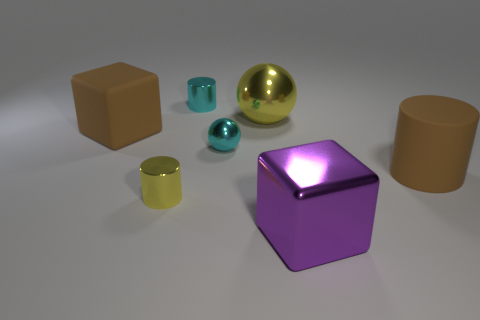Are there any large cubes in front of the yellow ball?
Provide a succinct answer. Yes. Are there any other tiny metallic objects of the same shape as the purple object?
Your answer should be compact. No. There is a yellow thing that is the same size as the brown rubber block; what shape is it?
Your answer should be compact. Sphere. How many things are either big brown cubes to the left of the tiny cyan shiny ball or tiny metal cylinders?
Offer a very short reply. 3. Do the rubber cube and the matte cylinder have the same color?
Offer a very short reply. Yes. What size is the rubber thing on the left side of the large yellow shiny sphere?
Offer a terse response. Large. Is there a rubber cube of the same size as the yellow metal ball?
Offer a very short reply. Yes. There is a metallic cylinder behind the yellow shiny sphere; is its size the same as the brown block?
Your answer should be compact. No. The brown matte cylinder is what size?
Keep it short and to the point. Large. There is a large metal thing that is on the left side of the purple metal block in front of the cyan object in front of the large yellow object; what is its color?
Keep it short and to the point. Yellow. 